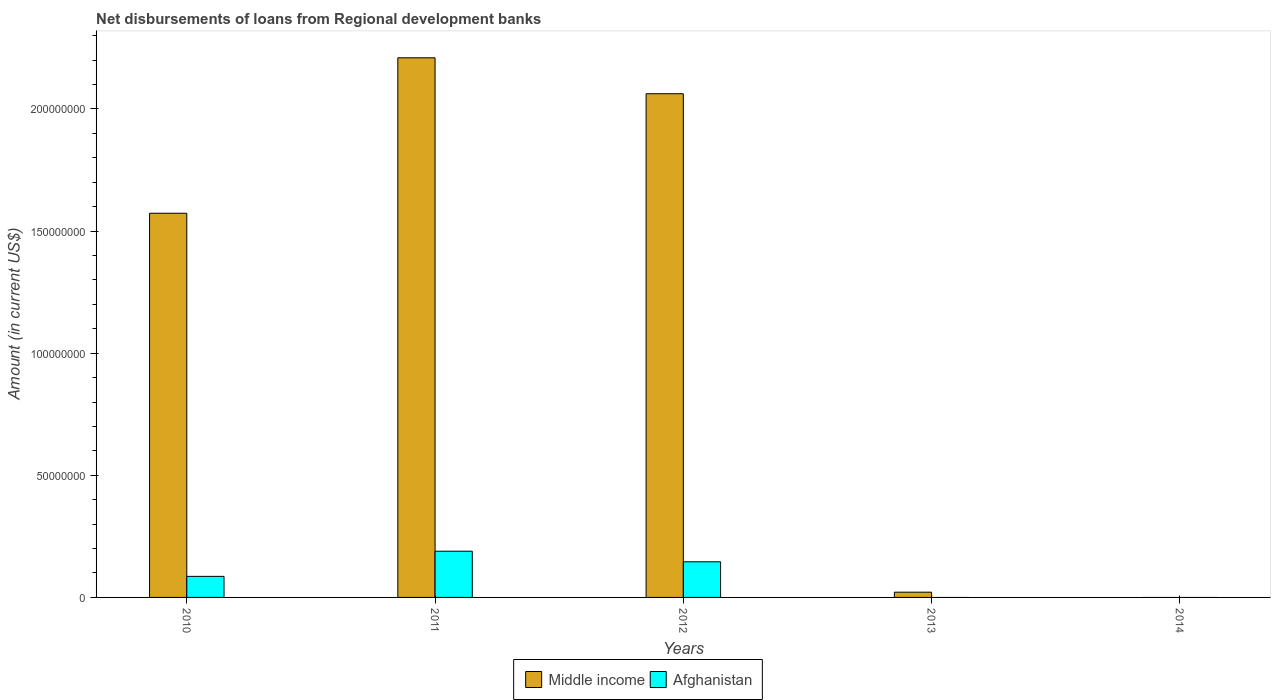How many different coloured bars are there?
Ensure brevity in your answer.  2. How many bars are there on the 3rd tick from the left?
Your answer should be compact. 2. How many bars are there on the 5th tick from the right?
Your response must be concise. 2. What is the label of the 2nd group of bars from the left?
Your answer should be compact. 2011. What is the amount of disbursements of loans from regional development banks in Middle income in 2010?
Offer a terse response. 1.57e+08. Across all years, what is the maximum amount of disbursements of loans from regional development banks in Afghanistan?
Ensure brevity in your answer.  1.89e+07. What is the total amount of disbursements of loans from regional development banks in Middle income in the graph?
Your response must be concise. 5.87e+08. What is the difference between the amount of disbursements of loans from regional development banks in Middle income in 2010 and that in 2011?
Your response must be concise. -6.36e+07. What is the difference between the amount of disbursements of loans from regional development banks in Afghanistan in 2014 and the amount of disbursements of loans from regional development banks in Middle income in 2013?
Provide a short and direct response. -2.15e+06. What is the average amount of disbursements of loans from regional development banks in Afghanistan per year?
Provide a short and direct response. 8.43e+06. In the year 2012, what is the difference between the amount of disbursements of loans from regional development banks in Middle income and amount of disbursements of loans from regional development banks in Afghanistan?
Your answer should be compact. 1.92e+08. What is the ratio of the amount of disbursements of loans from regional development banks in Middle income in 2010 to that in 2013?
Give a very brief answer. 73.14. Is the amount of disbursements of loans from regional development banks in Middle income in 2010 less than that in 2012?
Offer a very short reply. Yes. What is the difference between the highest and the second highest amount of disbursements of loans from regional development banks in Afghanistan?
Provide a short and direct response. 4.33e+06. What is the difference between the highest and the lowest amount of disbursements of loans from regional development banks in Middle income?
Provide a succinct answer. 2.21e+08. In how many years, is the amount of disbursements of loans from regional development banks in Afghanistan greater than the average amount of disbursements of loans from regional development banks in Afghanistan taken over all years?
Make the answer very short. 3. Is the sum of the amount of disbursements of loans from regional development banks in Middle income in 2011 and 2013 greater than the maximum amount of disbursements of loans from regional development banks in Afghanistan across all years?
Give a very brief answer. Yes. Are the values on the major ticks of Y-axis written in scientific E-notation?
Provide a short and direct response. No. Does the graph contain any zero values?
Your response must be concise. Yes. What is the title of the graph?
Your response must be concise. Net disbursements of loans from Regional development banks. What is the label or title of the Y-axis?
Ensure brevity in your answer.  Amount (in current US$). What is the Amount (in current US$) in Middle income in 2010?
Offer a terse response. 1.57e+08. What is the Amount (in current US$) of Afghanistan in 2010?
Offer a terse response. 8.62e+06. What is the Amount (in current US$) of Middle income in 2011?
Your response must be concise. 2.21e+08. What is the Amount (in current US$) in Afghanistan in 2011?
Ensure brevity in your answer.  1.89e+07. What is the Amount (in current US$) in Middle income in 2012?
Make the answer very short. 2.06e+08. What is the Amount (in current US$) of Afghanistan in 2012?
Your answer should be very brief. 1.46e+07. What is the Amount (in current US$) of Middle income in 2013?
Ensure brevity in your answer.  2.15e+06. What is the Amount (in current US$) of Afghanistan in 2013?
Offer a terse response. 0. What is the Amount (in current US$) of Middle income in 2014?
Give a very brief answer. 0. Across all years, what is the maximum Amount (in current US$) in Middle income?
Your answer should be compact. 2.21e+08. Across all years, what is the maximum Amount (in current US$) of Afghanistan?
Ensure brevity in your answer.  1.89e+07. Across all years, what is the minimum Amount (in current US$) in Afghanistan?
Provide a short and direct response. 0. What is the total Amount (in current US$) of Middle income in the graph?
Keep it short and to the point. 5.87e+08. What is the total Amount (in current US$) of Afghanistan in the graph?
Your response must be concise. 4.21e+07. What is the difference between the Amount (in current US$) of Middle income in 2010 and that in 2011?
Provide a short and direct response. -6.36e+07. What is the difference between the Amount (in current US$) of Afghanistan in 2010 and that in 2011?
Your answer should be very brief. -1.03e+07. What is the difference between the Amount (in current US$) of Middle income in 2010 and that in 2012?
Your response must be concise. -4.89e+07. What is the difference between the Amount (in current US$) of Afghanistan in 2010 and that in 2012?
Ensure brevity in your answer.  -5.97e+06. What is the difference between the Amount (in current US$) in Middle income in 2010 and that in 2013?
Provide a succinct answer. 1.55e+08. What is the difference between the Amount (in current US$) of Middle income in 2011 and that in 2012?
Your answer should be very brief. 1.47e+07. What is the difference between the Amount (in current US$) of Afghanistan in 2011 and that in 2012?
Your response must be concise. 4.33e+06. What is the difference between the Amount (in current US$) of Middle income in 2011 and that in 2013?
Your answer should be very brief. 2.19e+08. What is the difference between the Amount (in current US$) in Middle income in 2012 and that in 2013?
Provide a succinct answer. 2.04e+08. What is the difference between the Amount (in current US$) of Middle income in 2010 and the Amount (in current US$) of Afghanistan in 2011?
Give a very brief answer. 1.38e+08. What is the difference between the Amount (in current US$) in Middle income in 2010 and the Amount (in current US$) in Afghanistan in 2012?
Ensure brevity in your answer.  1.43e+08. What is the difference between the Amount (in current US$) in Middle income in 2011 and the Amount (in current US$) in Afghanistan in 2012?
Offer a very short reply. 2.06e+08. What is the average Amount (in current US$) in Middle income per year?
Ensure brevity in your answer.  1.17e+08. What is the average Amount (in current US$) of Afghanistan per year?
Your response must be concise. 8.43e+06. In the year 2010, what is the difference between the Amount (in current US$) of Middle income and Amount (in current US$) of Afghanistan?
Your answer should be compact. 1.49e+08. In the year 2011, what is the difference between the Amount (in current US$) in Middle income and Amount (in current US$) in Afghanistan?
Ensure brevity in your answer.  2.02e+08. In the year 2012, what is the difference between the Amount (in current US$) in Middle income and Amount (in current US$) in Afghanistan?
Provide a short and direct response. 1.92e+08. What is the ratio of the Amount (in current US$) of Middle income in 2010 to that in 2011?
Your answer should be compact. 0.71. What is the ratio of the Amount (in current US$) of Afghanistan in 2010 to that in 2011?
Give a very brief answer. 0.46. What is the ratio of the Amount (in current US$) of Middle income in 2010 to that in 2012?
Give a very brief answer. 0.76. What is the ratio of the Amount (in current US$) of Afghanistan in 2010 to that in 2012?
Offer a very short reply. 0.59. What is the ratio of the Amount (in current US$) in Middle income in 2010 to that in 2013?
Ensure brevity in your answer.  73.14. What is the ratio of the Amount (in current US$) in Middle income in 2011 to that in 2012?
Ensure brevity in your answer.  1.07. What is the ratio of the Amount (in current US$) in Afghanistan in 2011 to that in 2012?
Keep it short and to the point. 1.3. What is the ratio of the Amount (in current US$) of Middle income in 2011 to that in 2013?
Make the answer very short. 102.74. What is the ratio of the Amount (in current US$) of Middle income in 2012 to that in 2013?
Offer a terse response. 95.9. What is the difference between the highest and the second highest Amount (in current US$) in Middle income?
Keep it short and to the point. 1.47e+07. What is the difference between the highest and the second highest Amount (in current US$) of Afghanistan?
Your response must be concise. 4.33e+06. What is the difference between the highest and the lowest Amount (in current US$) of Middle income?
Provide a short and direct response. 2.21e+08. What is the difference between the highest and the lowest Amount (in current US$) in Afghanistan?
Offer a terse response. 1.89e+07. 